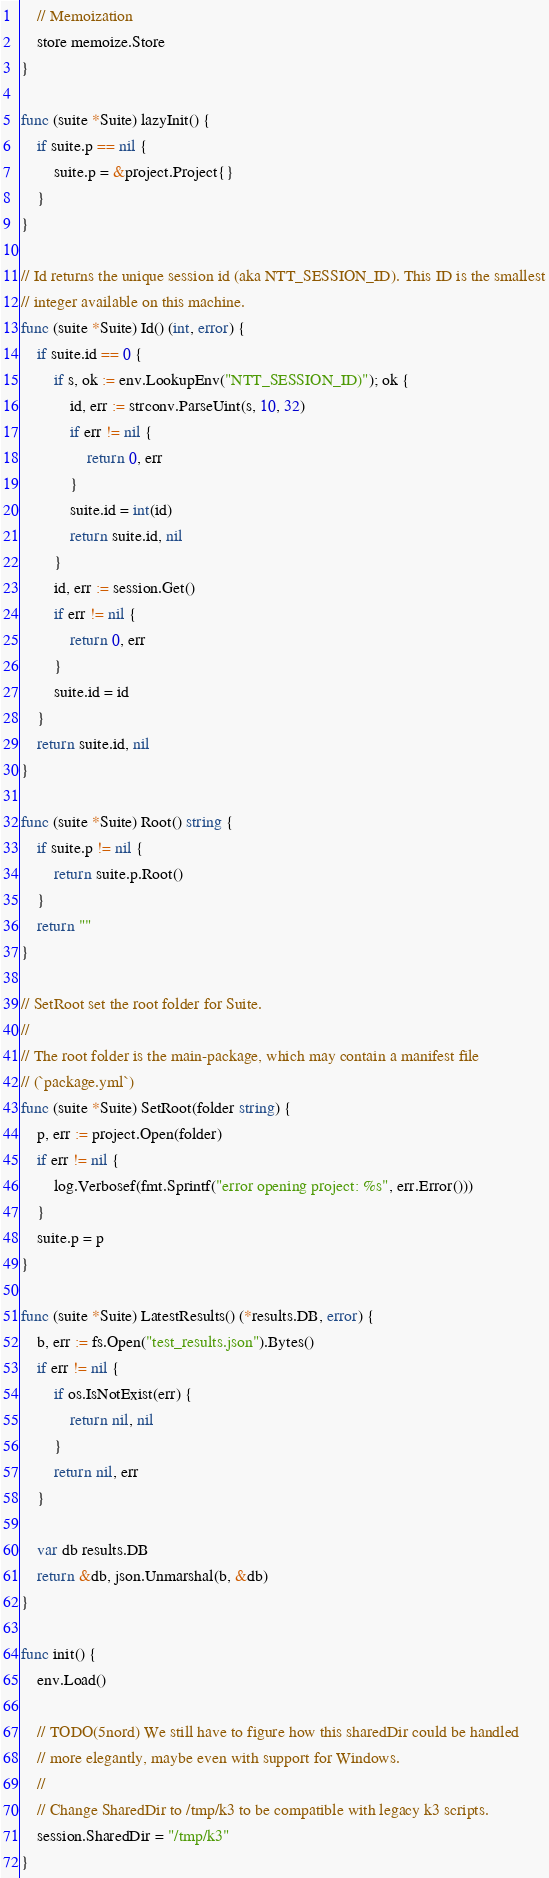<code> <loc_0><loc_0><loc_500><loc_500><_Go_>
	// Memoization
	store memoize.Store
}

func (suite *Suite) lazyInit() {
	if suite.p == nil {
		suite.p = &project.Project{}
	}
}

// Id returns the unique session id (aka NTT_SESSION_ID). This ID is the smallest
// integer available on this machine.
func (suite *Suite) Id() (int, error) {
	if suite.id == 0 {
		if s, ok := env.LookupEnv("NTT_SESSION_ID)"); ok {
			id, err := strconv.ParseUint(s, 10, 32)
			if err != nil {
				return 0, err
			}
			suite.id = int(id)
			return suite.id, nil
		}
		id, err := session.Get()
		if err != nil {
			return 0, err
		}
		suite.id = id
	}
	return suite.id, nil
}

func (suite *Suite) Root() string {
	if suite.p != nil {
		return suite.p.Root()
	}
	return ""
}

// SetRoot set the root folder for Suite.
//
// The root folder is the main-package, which may contain a manifest file
// (`package.yml`)
func (suite *Suite) SetRoot(folder string) {
	p, err := project.Open(folder)
	if err != nil {
		log.Verbosef(fmt.Sprintf("error opening project: %s", err.Error()))
	}
	suite.p = p
}

func (suite *Suite) LatestResults() (*results.DB, error) {
	b, err := fs.Open("test_results.json").Bytes()
	if err != nil {
		if os.IsNotExist(err) {
			return nil, nil
		}
		return nil, err
	}

	var db results.DB
	return &db, json.Unmarshal(b, &db)
}

func init() {
	env.Load()

	// TODO(5nord) We still have to figure how this sharedDir could be handled
	// more elegantly, maybe even with support for Windows.
	//
	// Change SharedDir to /tmp/k3 to be compatible with legacy k3 scripts.
	session.SharedDir = "/tmp/k3"
}
</code> 